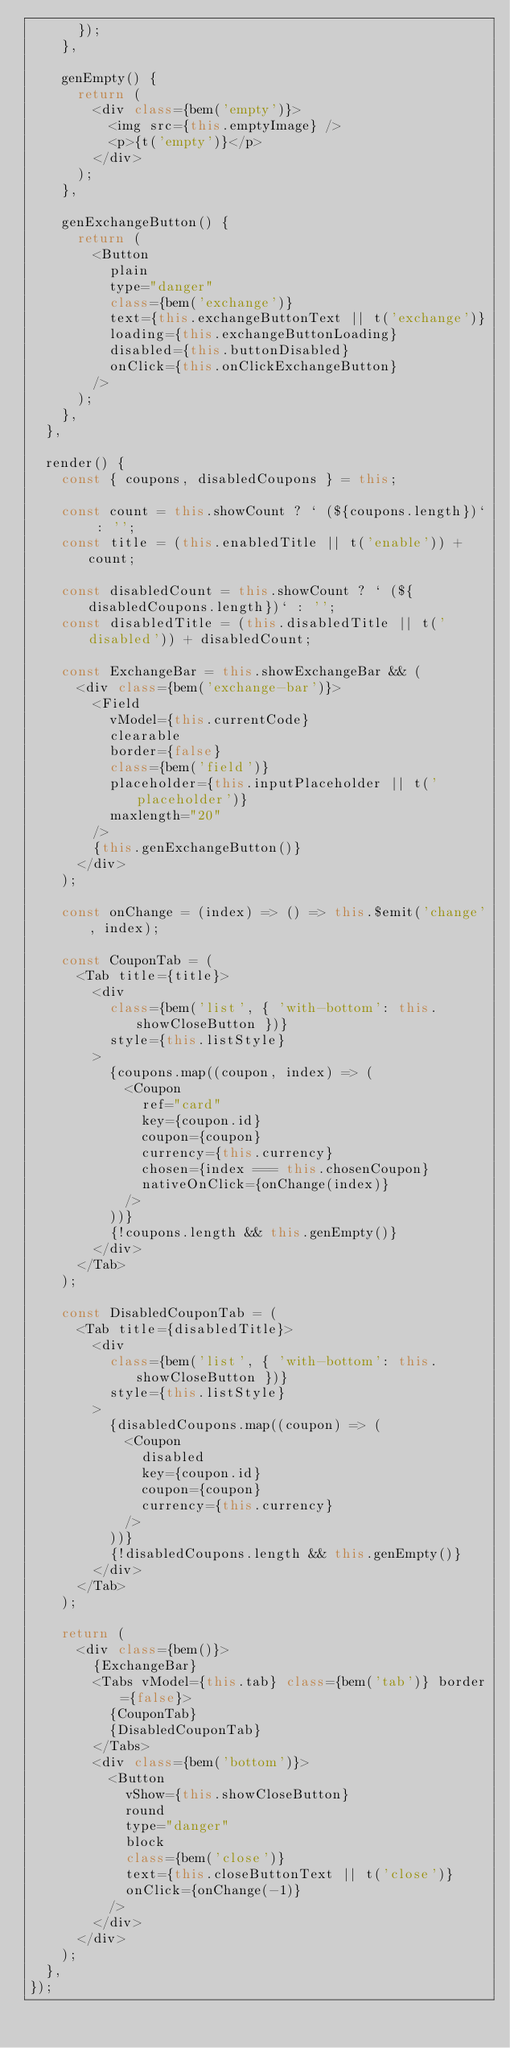<code> <loc_0><loc_0><loc_500><loc_500><_JavaScript_>      });
    },

    genEmpty() {
      return (
        <div class={bem('empty')}>
          <img src={this.emptyImage} />
          <p>{t('empty')}</p>
        </div>
      );
    },

    genExchangeButton() {
      return (
        <Button
          plain
          type="danger"
          class={bem('exchange')}
          text={this.exchangeButtonText || t('exchange')}
          loading={this.exchangeButtonLoading}
          disabled={this.buttonDisabled}
          onClick={this.onClickExchangeButton}
        />
      );
    },
  },

  render() {
    const { coupons, disabledCoupons } = this;

    const count = this.showCount ? ` (${coupons.length})` : '';
    const title = (this.enabledTitle || t('enable')) + count;

    const disabledCount = this.showCount ? ` (${disabledCoupons.length})` : '';
    const disabledTitle = (this.disabledTitle || t('disabled')) + disabledCount;

    const ExchangeBar = this.showExchangeBar && (
      <div class={bem('exchange-bar')}>
        <Field
          vModel={this.currentCode}
          clearable
          border={false}
          class={bem('field')}
          placeholder={this.inputPlaceholder || t('placeholder')}
          maxlength="20"
        />
        {this.genExchangeButton()}
      </div>
    );

    const onChange = (index) => () => this.$emit('change', index);

    const CouponTab = (
      <Tab title={title}>
        <div
          class={bem('list', { 'with-bottom': this.showCloseButton })}
          style={this.listStyle}
        >
          {coupons.map((coupon, index) => (
            <Coupon
              ref="card"
              key={coupon.id}
              coupon={coupon}
              currency={this.currency}
              chosen={index === this.chosenCoupon}
              nativeOnClick={onChange(index)}
            />
          ))}
          {!coupons.length && this.genEmpty()}
        </div>
      </Tab>
    );

    const DisabledCouponTab = (
      <Tab title={disabledTitle}>
        <div
          class={bem('list', { 'with-bottom': this.showCloseButton })}
          style={this.listStyle}
        >
          {disabledCoupons.map((coupon) => (
            <Coupon
              disabled
              key={coupon.id}
              coupon={coupon}
              currency={this.currency}
            />
          ))}
          {!disabledCoupons.length && this.genEmpty()}
        </div>
      </Tab>
    );

    return (
      <div class={bem()}>
        {ExchangeBar}
        <Tabs vModel={this.tab} class={bem('tab')} border={false}>
          {CouponTab}
          {DisabledCouponTab}
        </Tabs>
        <div class={bem('bottom')}>
          <Button
            vShow={this.showCloseButton}
            round
            type="danger"
            block
            class={bem('close')}
            text={this.closeButtonText || t('close')}
            onClick={onChange(-1)}
          />
        </div>
      </div>
    );
  },
});
</code> 